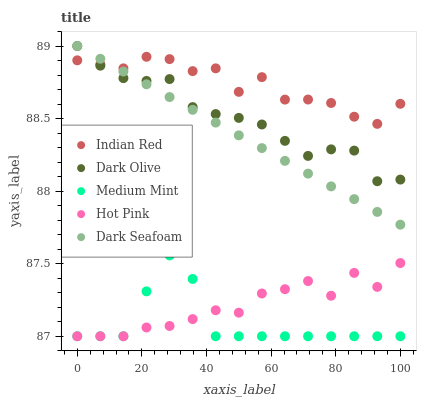Does Medium Mint have the minimum area under the curve?
Answer yes or no. Yes. Does Indian Red have the maximum area under the curve?
Answer yes or no. Yes. Does Dark Seafoam have the minimum area under the curve?
Answer yes or no. No. Does Dark Seafoam have the maximum area under the curve?
Answer yes or no. No. Is Dark Seafoam the smoothest?
Answer yes or no. Yes. Is Indian Red the roughest?
Answer yes or no. Yes. Is Dark Olive the smoothest?
Answer yes or no. No. Is Dark Olive the roughest?
Answer yes or no. No. Does Medium Mint have the lowest value?
Answer yes or no. Yes. Does Dark Seafoam have the lowest value?
Answer yes or no. No. Does Dark Olive have the highest value?
Answer yes or no. Yes. Does Indian Red have the highest value?
Answer yes or no. No. Is Hot Pink less than Dark Olive?
Answer yes or no. Yes. Is Indian Red greater than Medium Mint?
Answer yes or no. Yes. Does Dark Olive intersect Indian Red?
Answer yes or no. Yes. Is Dark Olive less than Indian Red?
Answer yes or no. No. Is Dark Olive greater than Indian Red?
Answer yes or no. No. Does Hot Pink intersect Dark Olive?
Answer yes or no. No. 